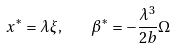Convert formula to latex. <formula><loc_0><loc_0><loc_500><loc_500>x ^ { * } = \lambda \xi , \quad \beta ^ { * } = - \frac { \lambda ^ { 3 } } { 2 b } \Omega</formula> 